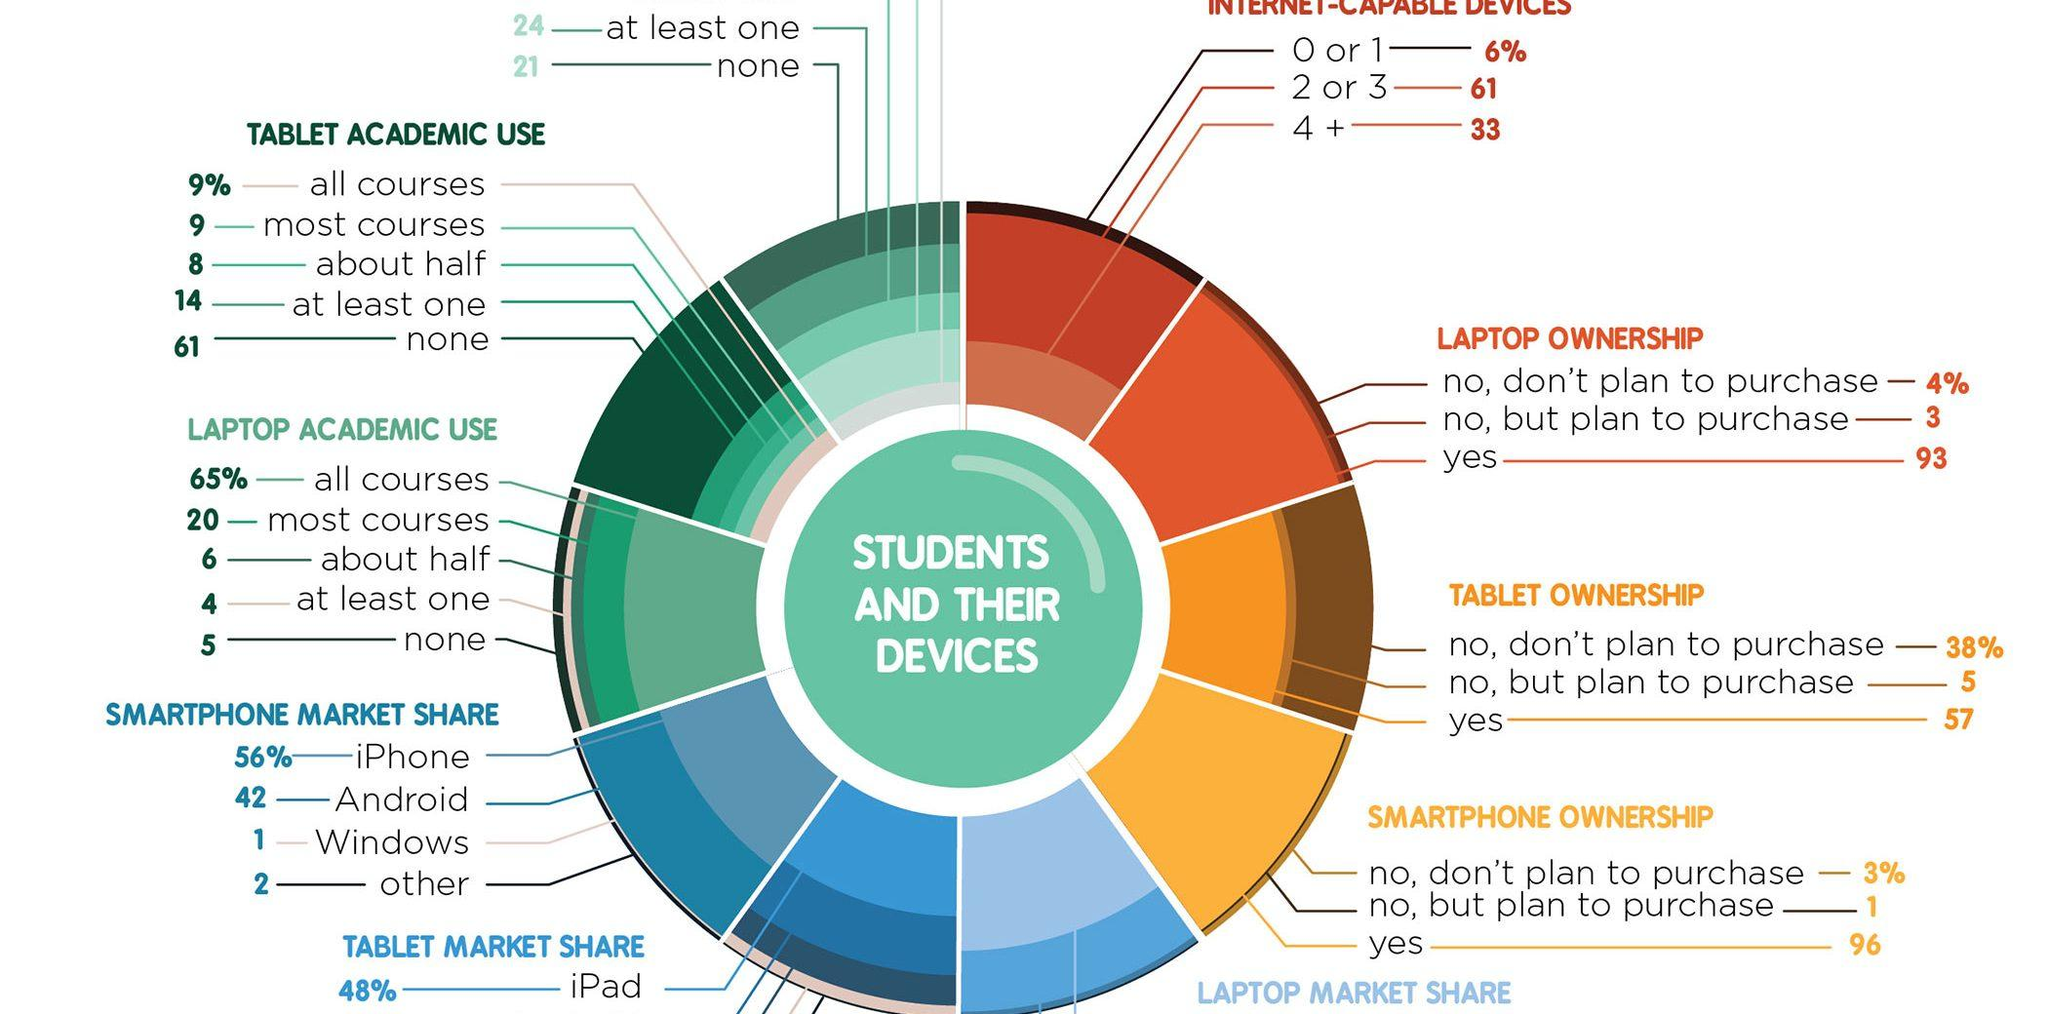Draw attention to some important aspects in this diagram. The most popular smartphone in the market is the iPhone. According to the data, 18% of students use tablets for all of their courses and most courses. A small percentage of students, just 3%, will not purchase a smartphone. It is expected that a significant majority of students, approximately 93%, will purchase laptops. 